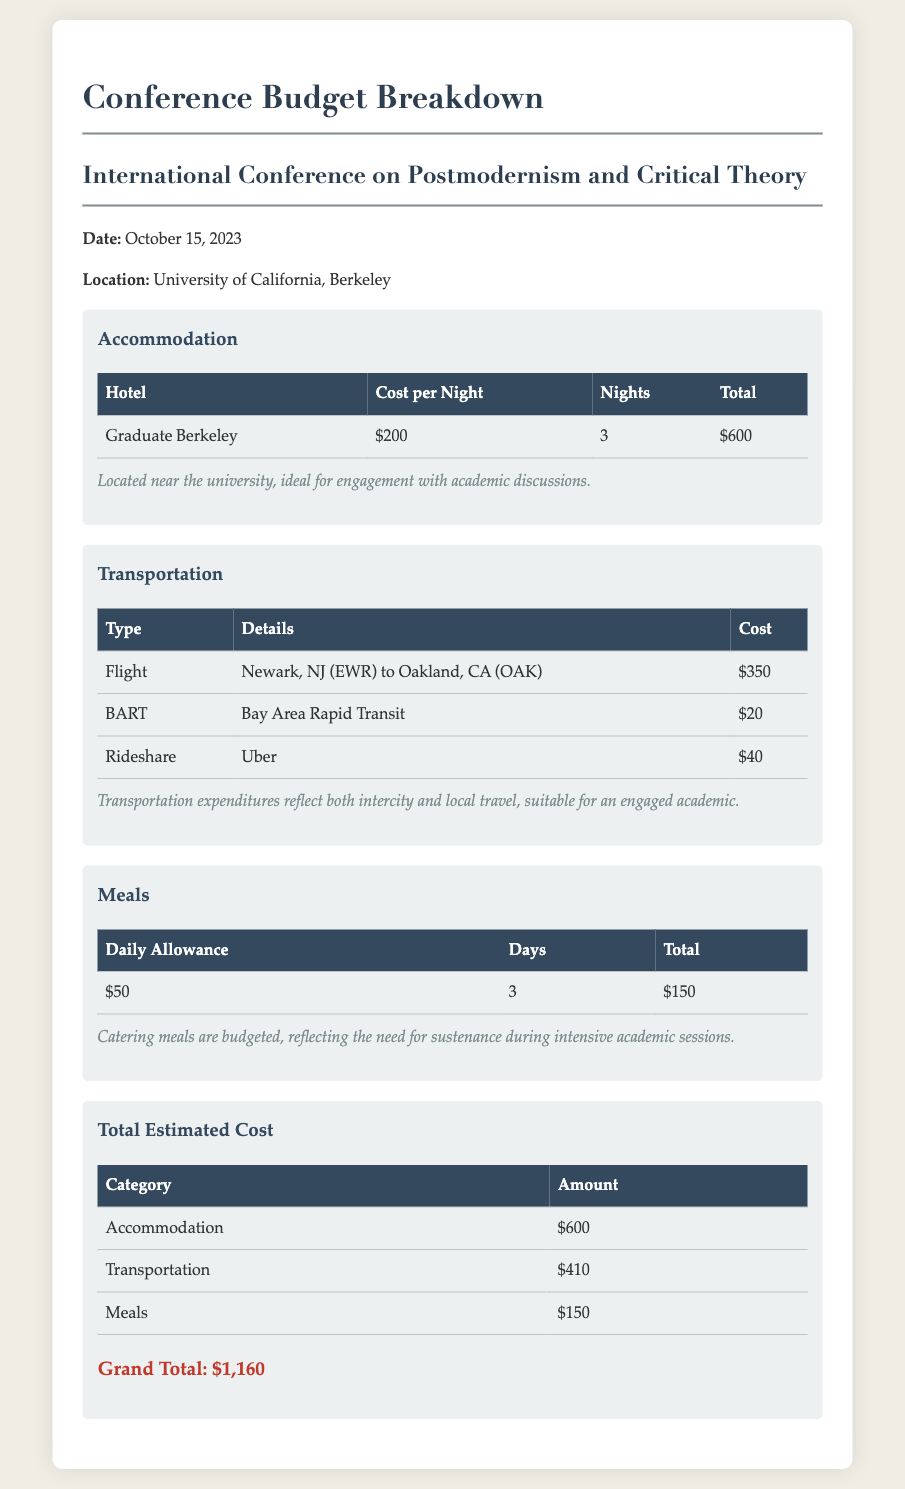What is the date of the conference? The date of the conference is explicitly stated in the document.
Answer: October 15, 2023 What is the location of the conference? The location of the conference is clearly mentioned in the document.
Answer: University of California, Berkeley How much was spent on accommodation? The total accommodation cost is provided in a clearly labeled section of the document.
Answer: $600 What was the cost of the flight from Newark, NJ to Oakland, CA? The flight cost is explicitly detailed in the transportation section of the document.
Answer: $350 What is the daily allowance for meals? The daily allowance for meals is specified in the meals section of the document.
Answer: $50 What is the total transportation cost? The total amount spent on transportation is calculated and provided in the budget breakdown.
Answer: $410 How many nights did the accommodation last? The number of nights for accommodation is listed in the accommodation table of the document.
Answer: 3 How much was budgeted for meals over the total days? The total meals cost is explicitly noted in the meals section of the document.
Answer: $150 What is the grand total of expenses listed? The grand total expense is calculated and highlighted in the budget breakdown at the end of the document.
Answer: $1,160 